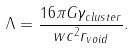<formula> <loc_0><loc_0><loc_500><loc_500>\Lambda = \frac { 1 6 \pi { G } { \gamma _ { c l u s t e r } } } { w { c ^ { 2 } } r _ { v o i d } } .</formula> 